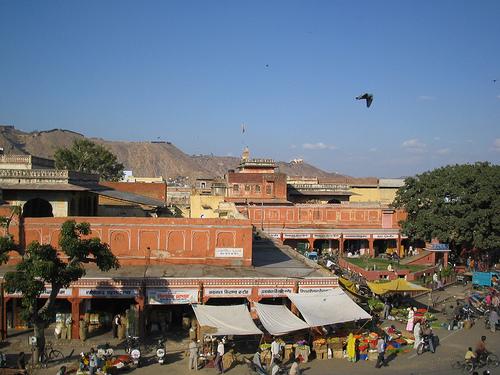What is in the sky?
Quick response, please. Bird. Where is the picture taken?
Be succinct. Market. Where is the bird?
Give a very brief answer. Sky. Are people shopping?
Give a very brief answer. Yes. Do the buildings have flat roofs?
Short answer required. Yes. IS it raining?
Quick response, please. No. 